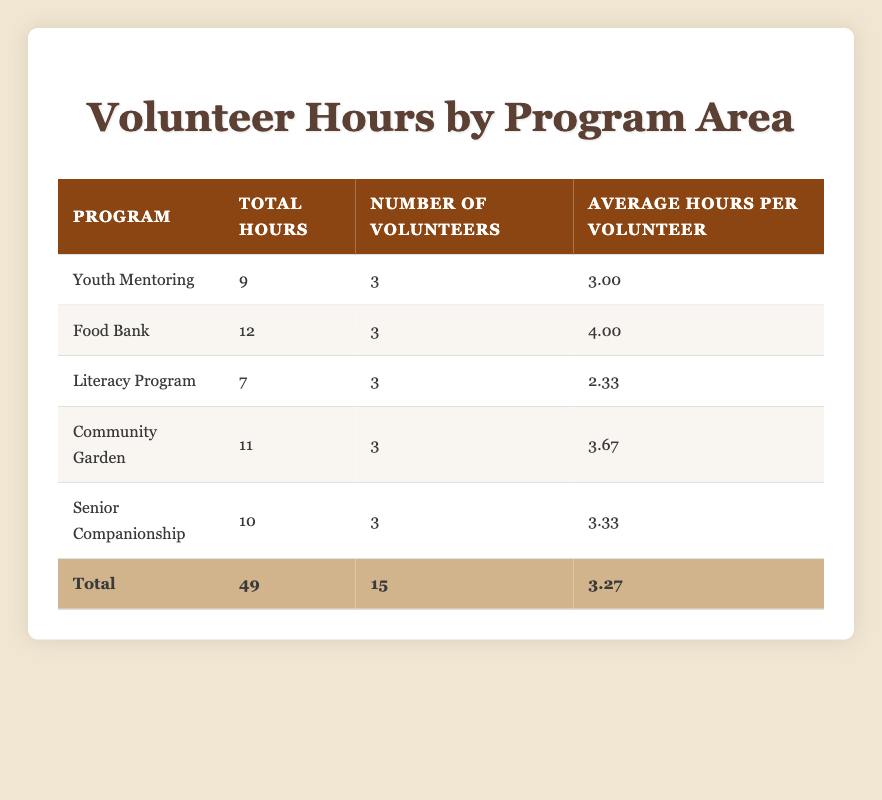What is the total number of volunteer hours logged in the Food Bank program? The table lists the total hours for each program area. For the Food Bank, the total hours is directly provided as 12.
Answer: 12 How many volunteers participated in the Literacy Program? The table shows the number of volunteers for each program area. For the Literacy Program, it states there are 3 volunteers.
Answer: 3 What is the average number of hours logged per volunteer in the Community Garden program? The table indicates that the Community Garden has total hours of 11 and 3 volunteers. To find the average, we divide 11 by 3, which equals approximately 3.67.
Answer: 3.67 Did more total hours get logged in the Youth Mentoring program than in the Literacy Program? The total hours for Youth Mentoring is 9, while Literacy Program has a total of 7 hours. Since 9 is greater than 7, the statement is true.
Answer: Yes How many more total hours were logged in the Senior Companionship program compared to the Literacy Program? For Senior Companionship, the total hours is 10, and for Literacy Program, it is 7. The difference is calculated as 10 - 7, which equals 3.
Answer: 3 What is the average total hours logged across all programs? The table provides the total hours for all programs as 49 and the number of programs is 5. To find the average, we divide 49 by 5, which equals 9.8.
Answer: 9.8 Identify the program with the highest average hours per volunteer. The table indicates that the Food Bank has the highest average hours per volunteer at 4.00. We compare all averages: Youth Mentoring (3.00), Food Bank (4.00), Literacy Program (2.33), Community Garden (3.67), and Senior Companionship (3.33) to find that Food Bank is the highest.
Answer: Food Bank How many volunteers contributed a total of 10 hours across programs? The table states the total hours for each program. To find volunteers contributing 10 hours across programs, we analyze the data: each program has a maximum of 3 volunteers, so there are no volunteers contributing a cumulative 10 hours as the maximum in any single program is below this.
Answer: No 